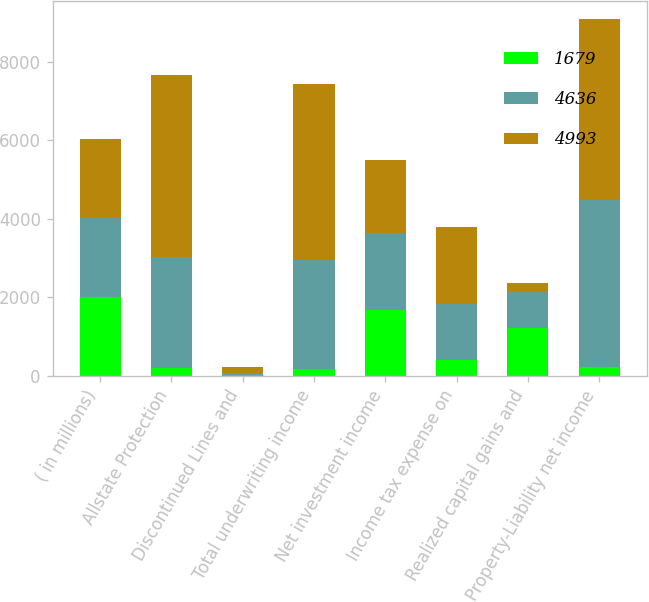Convert chart to OTSL. <chart><loc_0><loc_0><loc_500><loc_500><stacked_bar_chart><ecel><fcel>( in millions)<fcel>Allstate Protection<fcel>Discontinued Lines and<fcel>Total underwriting income<fcel>Net investment income<fcel>Income tax expense on<fcel>Realized capital gains and<fcel>Property-Liability net income<nl><fcel>1679<fcel>2008<fcel>189<fcel>25<fcel>164<fcel>1674<fcel>401<fcel>1209<fcel>228<nl><fcel>4636<fcel>2007<fcel>2838<fcel>54<fcel>2784<fcel>1972<fcel>1413<fcel>915<fcel>4258<nl><fcel>4993<fcel>2006<fcel>4636<fcel>139<fcel>4497<fcel>1854<fcel>1963<fcel>227<fcel>4614<nl></chart> 